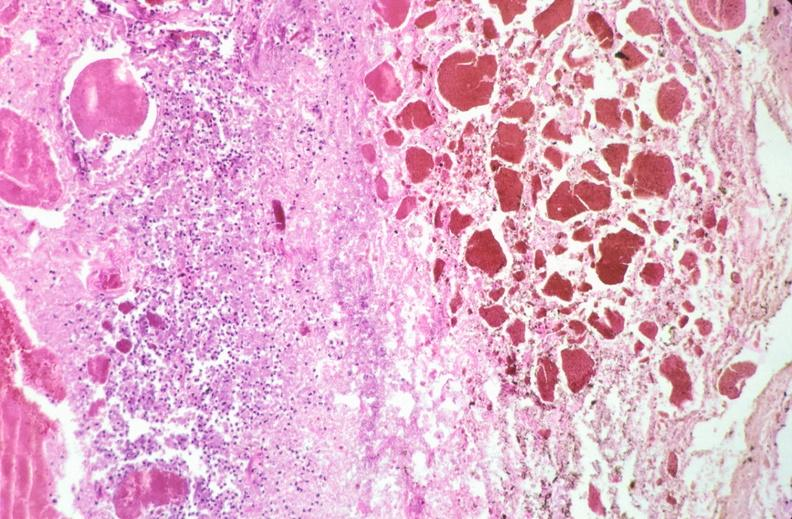s gastrointestinal present?
Answer the question using a single word or phrase. Yes 